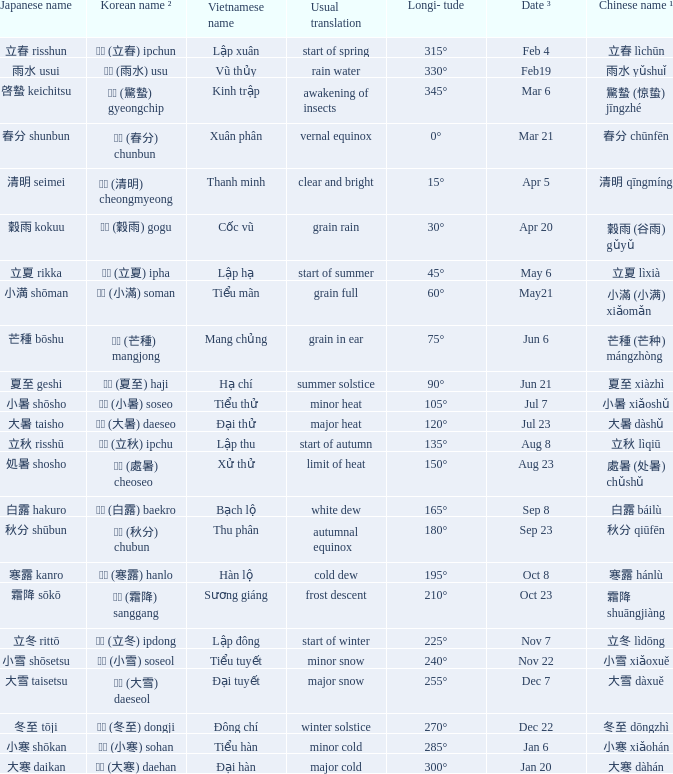WHich Usual translation is on sep 23? Autumnal equinox. 